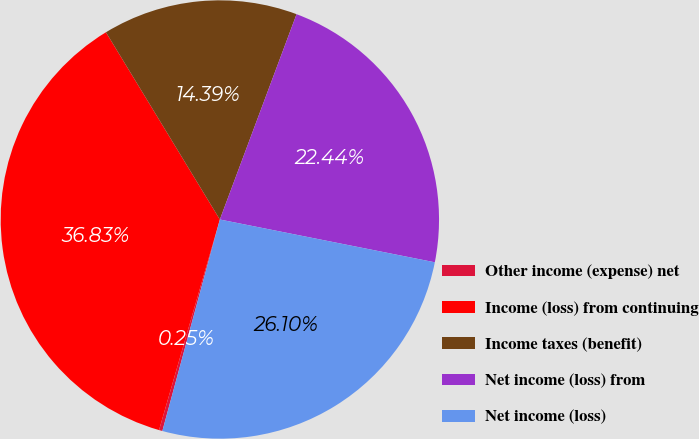Convert chart. <chart><loc_0><loc_0><loc_500><loc_500><pie_chart><fcel>Other income (expense) net<fcel>Income (loss) from continuing<fcel>Income taxes (benefit)<fcel>Net income (loss) from<fcel>Net income (loss)<nl><fcel>0.25%<fcel>36.83%<fcel>14.39%<fcel>22.44%<fcel>26.1%<nl></chart> 